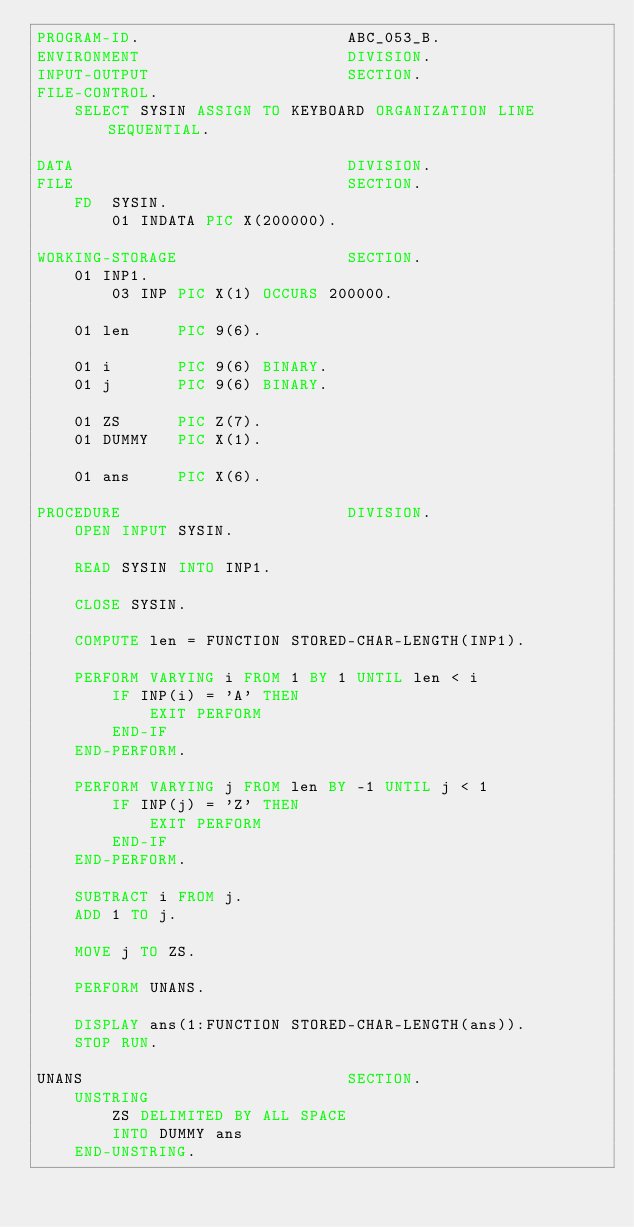<code> <loc_0><loc_0><loc_500><loc_500><_COBOL_>PROGRAM-ID.                      ABC_053_B.
ENVIRONMENT                      DIVISION.
INPUT-OUTPUT                     SECTION.
FILE-CONTROL.
    SELECT SYSIN ASSIGN TO KEYBOARD ORGANIZATION LINE SEQUENTIAL.

DATA                             DIVISION.
FILE                             SECTION.
    FD  SYSIN.
        01 INDATA PIC X(200000).

WORKING-STORAGE                  SECTION.
    01 INP1.
        03 INP PIC X(1) OCCURS 200000.

    01 len     PIC 9(6).

    01 i       PIC 9(6) BINARY.
    01 j       PIC 9(6) BINARY.

    01 ZS      PIC Z(7).
    01 DUMMY   PIC X(1).

    01 ans     PIC X(6).

PROCEDURE                        DIVISION.
    OPEN INPUT SYSIN.

    READ SYSIN INTO INP1.

    CLOSE SYSIN.

    COMPUTE len = FUNCTION STORED-CHAR-LENGTH(INP1).

    PERFORM VARYING i FROM 1 BY 1 UNTIL len < i
        IF INP(i) = 'A' THEN
            EXIT PERFORM
        END-IF
    END-PERFORM.

    PERFORM VARYING j FROM len BY -1 UNTIL j < 1
        IF INP(j) = 'Z' THEN
            EXIT PERFORM
        END-IF
    END-PERFORM.

    SUBTRACT i FROM j.
    ADD 1 TO j.

    MOVE j TO ZS.

    PERFORM UNANS.

    DISPLAY ans(1:FUNCTION STORED-CHAR-LENGTH(ans)).
    STOP RUN.

UNANS                            SECTION.
    UNSTRING
        ZS DELIMITED BY ALL SPACE
        INTO DUMMY ans
    END-UNSTRING.
</code> 